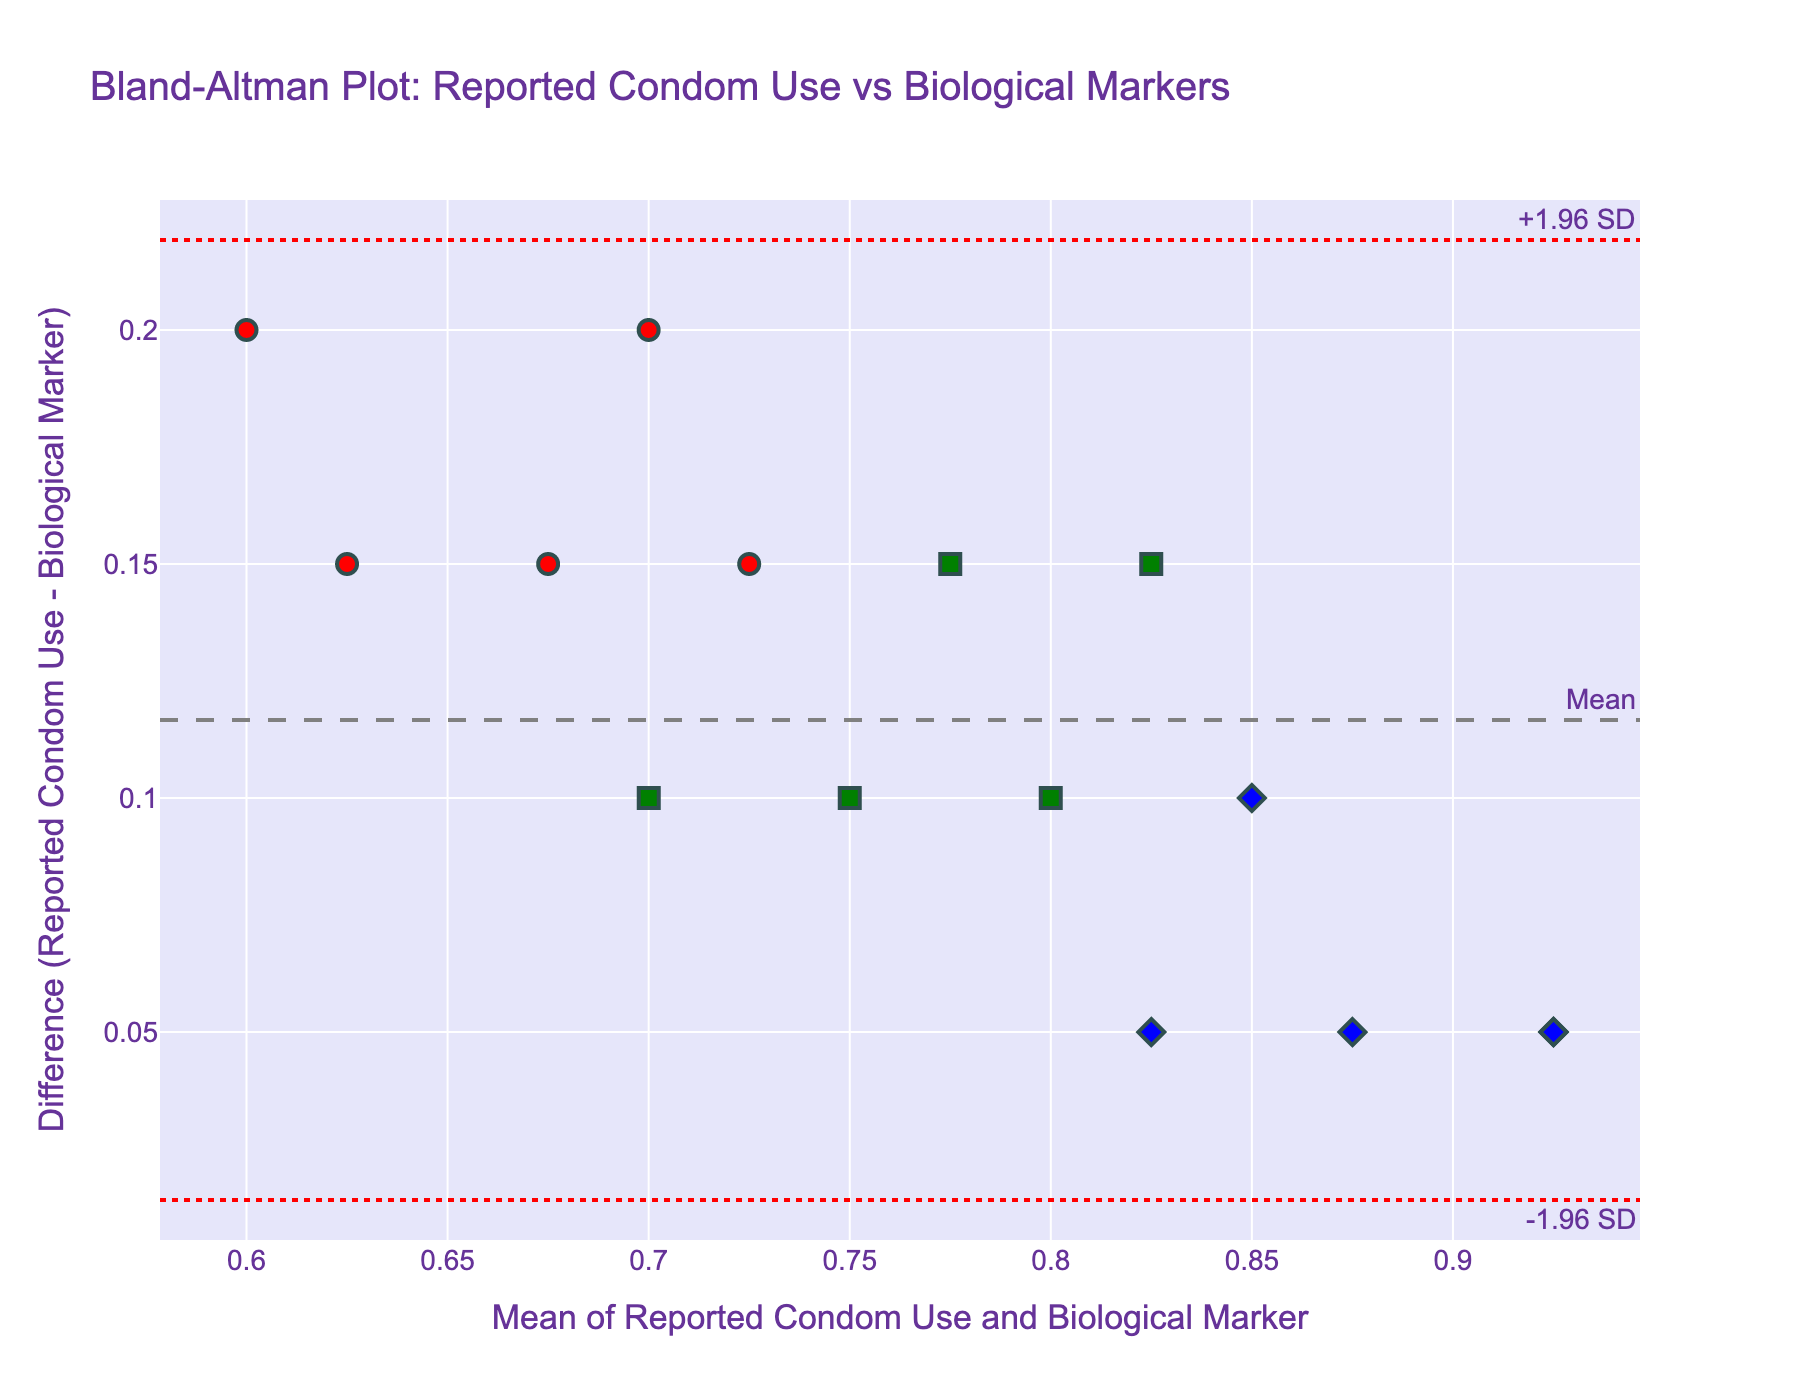How many participants are included in the plot? The plot shows individual data points for each participant and there are 15 markers visible on the scatter plot.
Answer: 15 What is the mean difference between reported condom use and the biological marker? The plot includes a dashed line indicating the mean difference, which is labeled.
Answer: Mean difference is labeled on the plot as a dashed grey line What are the limits of agreement for the differences? The plot shows the limits of agreement with a dotted red line, labeled as "-1.96 SD" and "+1.96 SD".
Answer: The limits are labeled on the plot as dotted red lines Which socioeconomic group shows the highest consistency between reported condom use and biological markers? To determine consistency, we need to look at the data points closest to the mean difference line. The "High-income" group, indicated by blue diamonds, shows points closest to the mean line.
Answer: High-income Are there any participants whose points fall outside the limits of agreement? We need to check if any points are outside the red dotted lines indicating the limits of agreement. None of the data points are outside the limits of agreement marked on the plot.
Answer: No Which participant is closest to the mean difference line? The participant whose data point is closest to the mean difference line, which can be identified as the dot closest to the grey dashed line, represents high consistency.
Answer: John What is the range of the means of reported condom use and biological markers? To find the range, identify the lowest and highest mean values on the x-axis of the plot. The x-axis shows a range approximately from 0.6 to 0.92.
Answer: 0.6 to 0.92 Which socioeconomic group is represented by square markers, and what color are they? The legend or the marker shapes and colors in the plot indicate that the "Middle-income" group is represented by green squares.
Answer: Middle-income, green How does the spread of differences compare between the socioeconomic groups? By visually assessing the scatter plot, we can see how spread out the differences are for each group's markers. "Low-income" (red circles) appears to have more spread than "High-income" (blue diamonds).
Answer: Low-income has more spread Considering the mean difference line, which socioeconomic group has data points consistently below this line? Look at the markers consistently below the grey dashed mean difference line. The "Low-income" group (red circles) has most of its data points below the mean line.
Answer: Low-income 